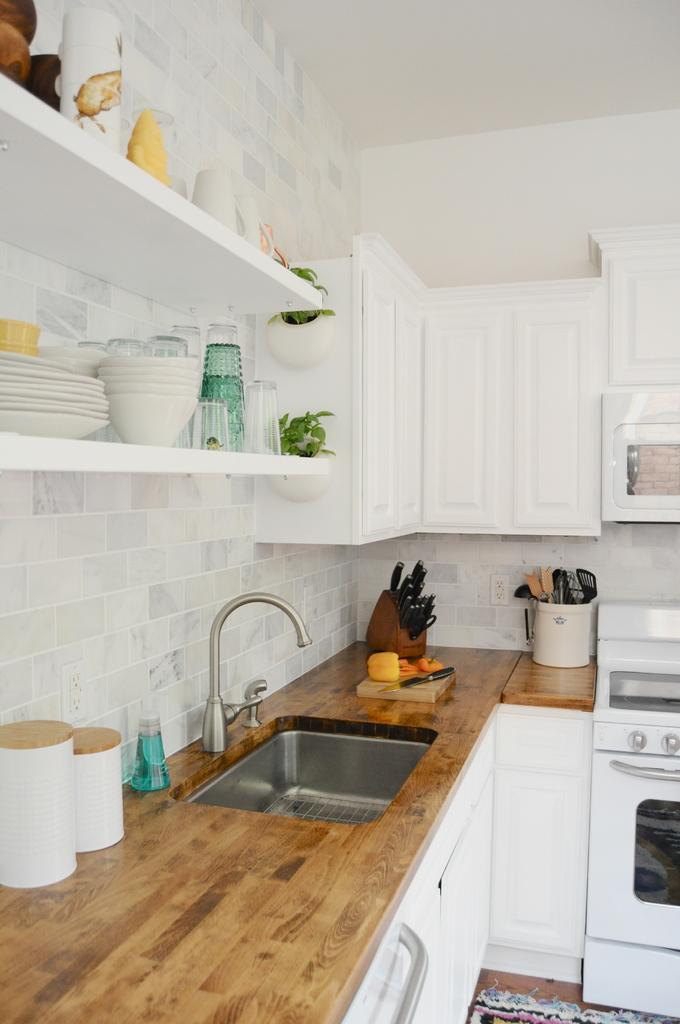Can you describe this image briefly? In this picture we can observe a brown color desk. There is a sink and a tank. We can observe some knives and kitchen accessories placed on the desk. We can observe plates and bowls placed in the racks. In the background we can observe white color cupboards and a wall. 